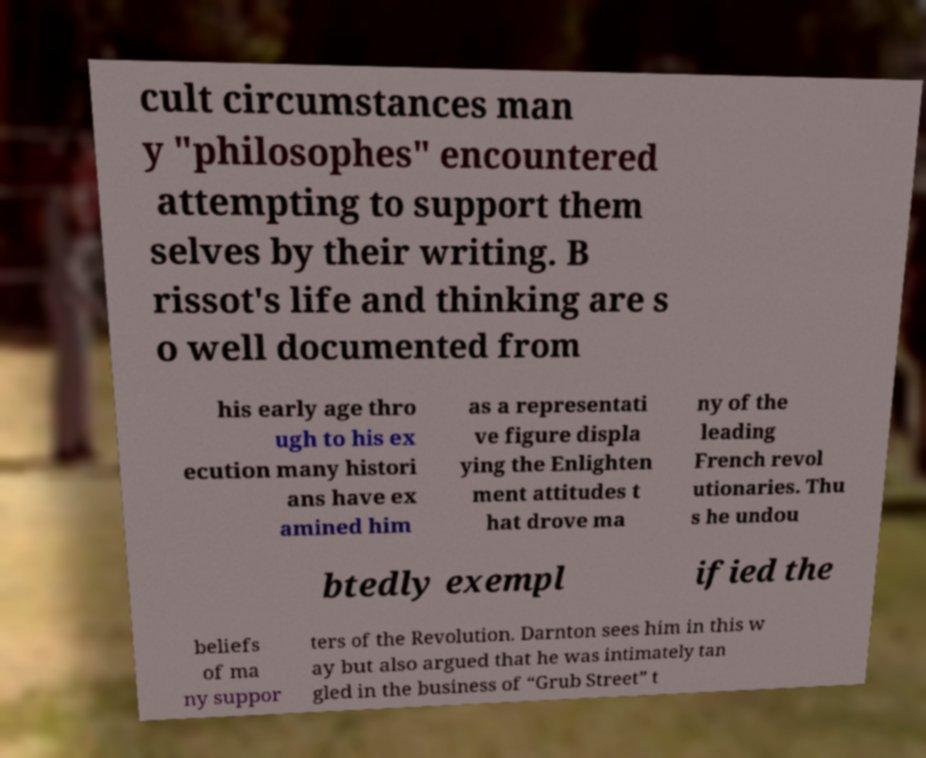Please identify and transcribe the text found in this image. cult circumstances man y "philosophes" encountered attempting to support them selves by their writing. B rissot's life and thinking are s o well documented from his early age thro ugh to his ex ecution many histori ans have ex amined him as a representati ve figure displa ying the Enlighten ment attitudes t hat drove ma ny of the leading French revol utionaries. Thu s he undou btedly exempl ified the beliefs of ma ny suppor ters of the Revolution. Darnton sees him in this w ay but also argued that he was intimately tan gled in the business of “Grub Street” t 